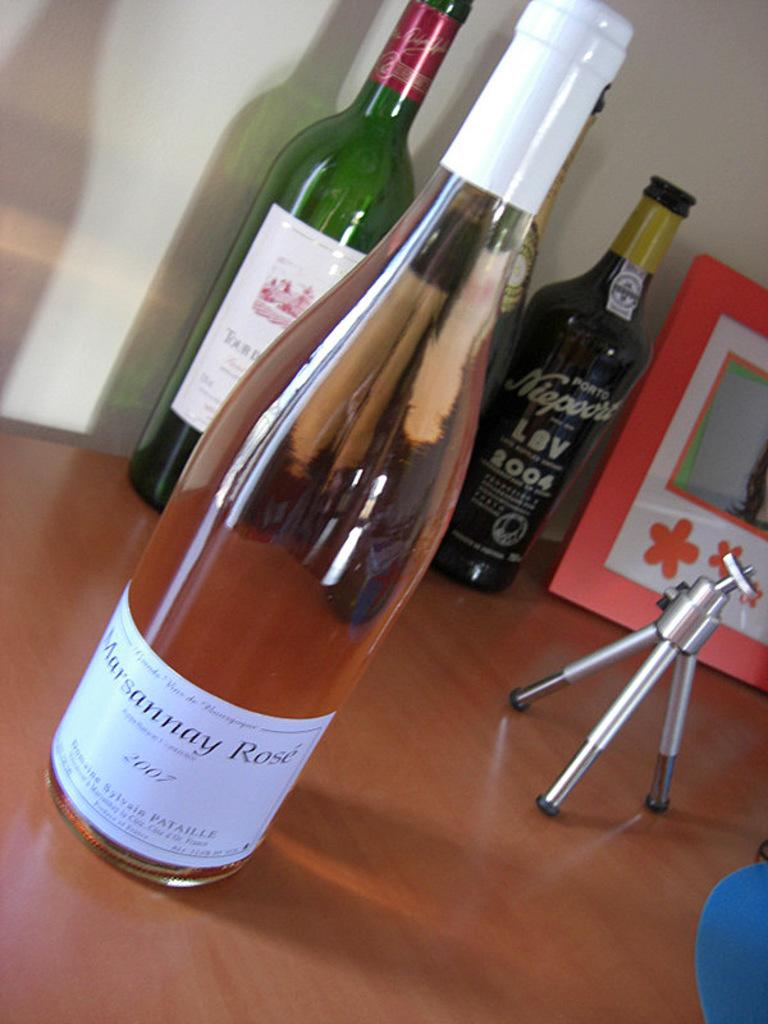Provide a one-sentence caption for the provided image. A bottle of Marsannay Rose from 2007 sits in front of some other wine bottles. 